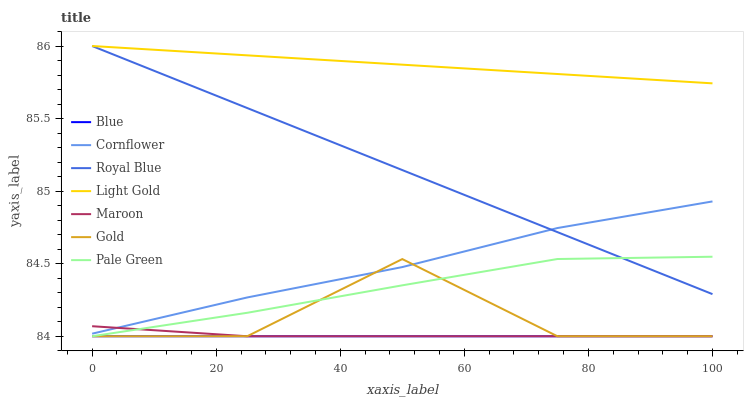Does Blue have the minimum area under the curve?
Answer yes or no. Yes. Does Light Gold have the maximum area under the curve?
Answer yes or no. Yes. Does Cornflower have the minimum area under the curve?
Answer yes or no. No. Does Cornflower have the maximum area under the curve?
Answer yes or no. No. Is Blue the smoothest?
Answer yes or no. Yes. Is Gold the roughest?
Answer yes or no. Yes. Is Cornflower the smoothest?
Answer yes or no. No. Is Cornflower the roughest?
Answer yes or no. No. Does Blue have the lowest value?
Answer yes or no. Yes. Does Cornflower have the lowest value?
Answer yes or no. No. Does Light Gold have the highest value?
Answer yes or no. Yes. Does Cornflower have the highest value?
Answer yes or no. No. Is Gold less than Light Gold?
Answer yes or no. Yes. Is Royal Blue greater than Gold?
Answer yes or no. Yes. Does Blue intersect Gold?
Answer yes or no. Yes. Is Blue less than Gold?
Answer yes or no. No. Is Blue greater than Gold?
Answer yes or no. No. Does Gold intersect Light Gold?
Answer yes or no. No. 